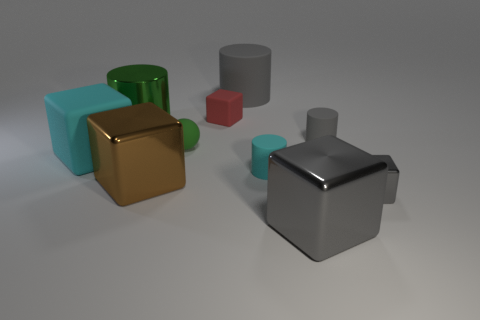Do the big shiny cylinder and the small metal block have the same color?
Your answer should be compact. No. The matte thing that is both in front of the tiny green matte ball and left of the big gray rubber cylinder is what color?
Give a very brief answer. Cyan. What number of balls are either tiny red objects or green objects?
Provide a short and direct response. 1. Are there fewer large shiny cylinders on the left side of the big green object than large brown shiny cylinders?
Give a very brief answer. No. What is the shape of the green thing that is the same material as the big brown thing?
Offer a terse response. Cylinder. What number of spheres are the same color as the big metal cylinder?
Your answer should be compact. 1. What number of objects are either green things or gray things?
Provide a succinct answer. 6. There is a tiny thing that is behind the green object that is to the left of the tiny green sphere; what is its material?
Offer a terse response. Rubber. Are there any green things made of the same material as the brown block?
Your response must be concise. Yes. What shape is the large matte thing in front of the gray rubber cylinder behind the tiny red object that is behind the small cyan object?
Offer a very short reply. Cube. 